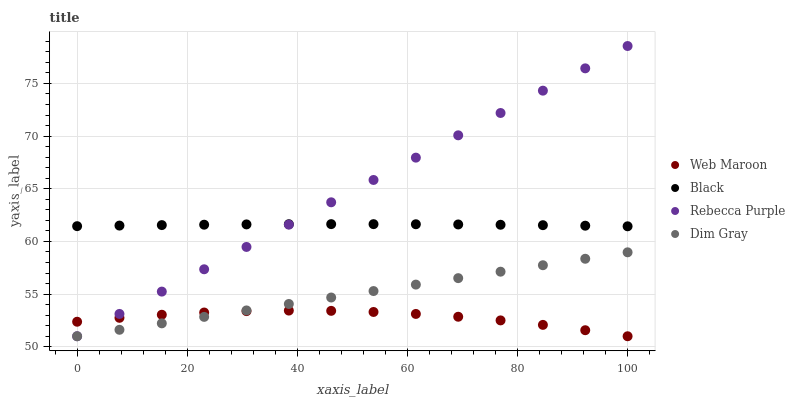Does Web Maroon have the minimum area under the curve?
Answer yes or no. Yes. Does Rebecca Purple have the maximum area under the curve?
Answer yes or no. Yes. Does Dim Gray have the minimum area under the curve?
Answer yes or no. No. Does Dim Gray have the maximum area under the curve?
Answer yes or no. No. Is Dim Gray the smoothest?
Answer yes or no. Yes. Is Web Maroon the roughest?
Answer yes or no. Yes. Is Web Maroon the smoothest?
Answer yes or no. No. Is Dim Gray the roughest?
Answer yes or no. No. Does Dim Gray have the lowest value?
Answer yes or no. Yes. Does Rebecca Purple have the highest value?
Answer yes or no. Yes. Does Dim Gray have the highest value?
Answer yes or no. No. Is Dim Gray less than Black?
Answer yes or no. Yes. Is Black greater than Web Maroon?
Answer yes or no. Yes. Does Black intersect Rebecca Purple?
Answer yes or no. Yes. Is Black less than Rebecca Purple?
Answer yes or no. No. Is Black greater than Rebecca Purple?
Answer yes or no. No. Does Dim Gray intersect Black?
Answer yes or no. No. 